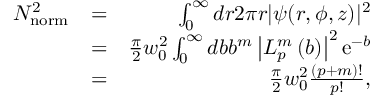<formula> <loc_0><loc_0><loc_500><loc_500>\begin{array} { r l r } { N _ { n o r m } ^ { 2 } } & { = } & { \int _ { 0 } ^ { \infty } d r 2 \pi r | \psi ( r , \phi , z ) | ^ { 2 } } \\ & { = } & { \frac { \pi } { 2 } w _ { 0 } ^ { 2 } \int _ { 0 } ^ { \infty } d b b ^ { m } \left | L _ { p } ^ { m } \left ( b \right ) \right | ^ { 2 } e ^ { - b } } \\ & { = } & { \frac { \pi } { 2 } w _ { 0 } ^ { 2 } \frac { ( p + m ) ! } { p ! } , } \end{array}</formula> 